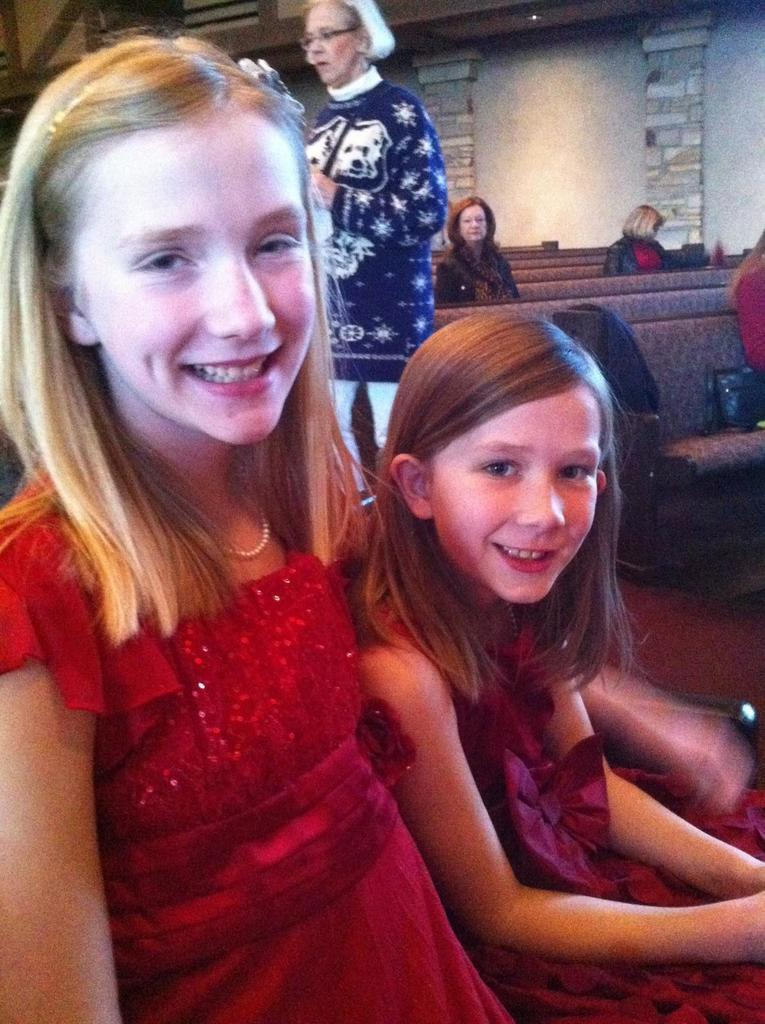How many girls are in the image? There are two girls in the image. What expression do the girls have? The girls are smiling. What can be seen in the background of the image? There are people sitting on chairs and a woman standing in the background. There is also a wall visible. What type of picture is hanging on the wall in the image? There is no picture hanging on the wall in the image; only a wall is visible in the background. Can you tell me how many bananas are on the table in the image? There are no bananas present in the image. 